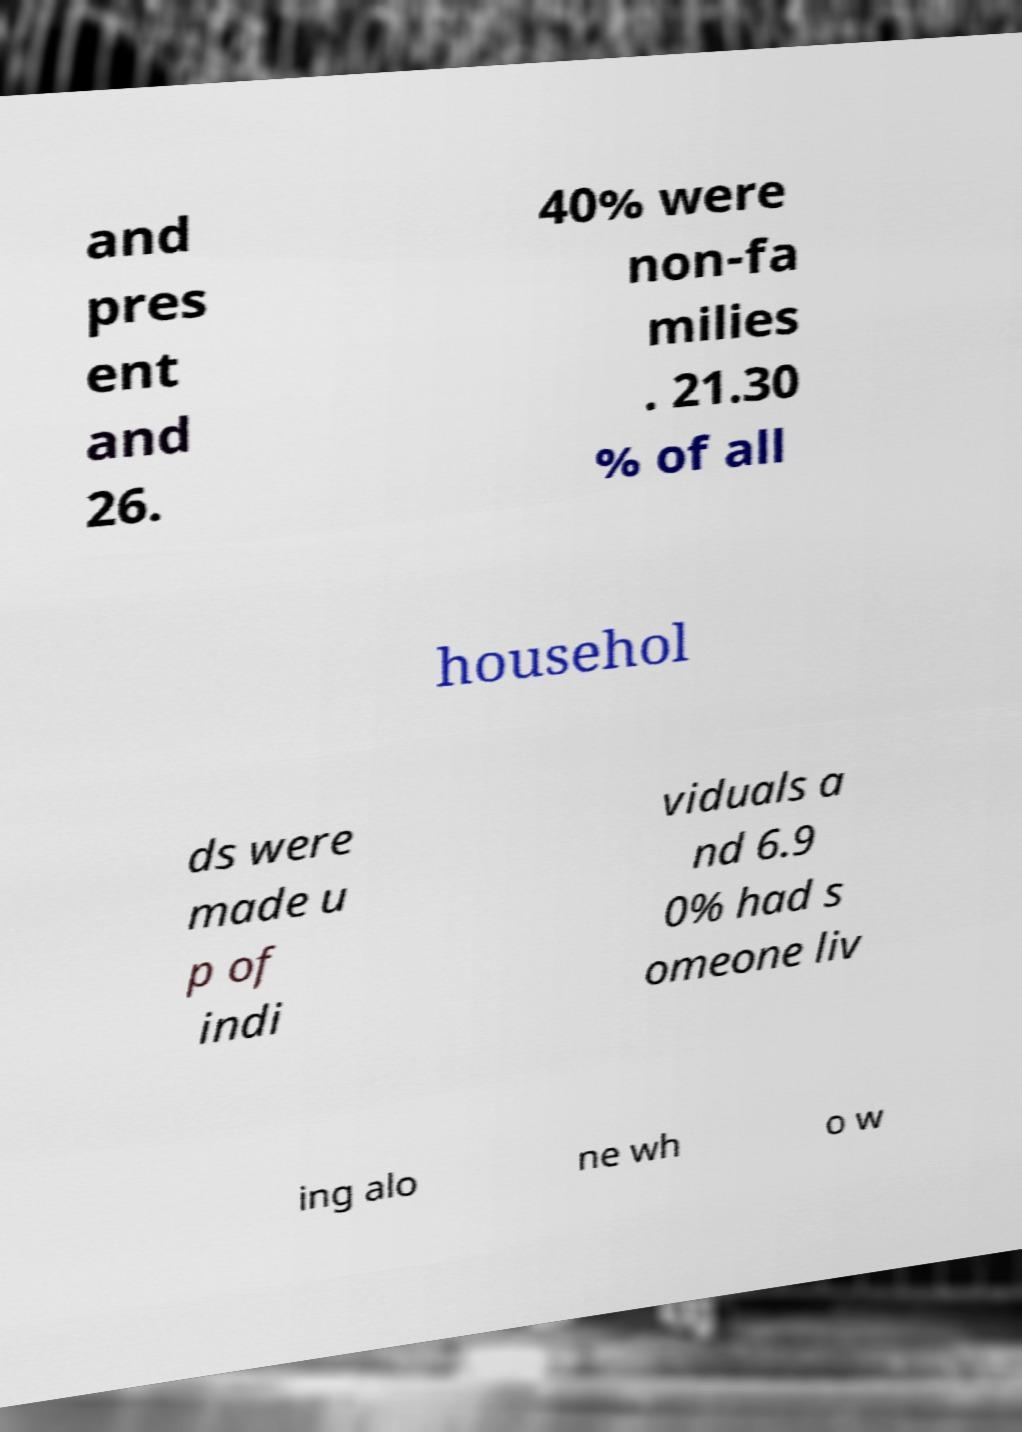Can you accurately transcribe the text from the provided image for me? and pres ent and 26. 40% were non-fa milies . 21.30 % of all househol ds were made u p of indi viduals a nd 6.9 0% had s omeone liv ing alo ne wh o w 